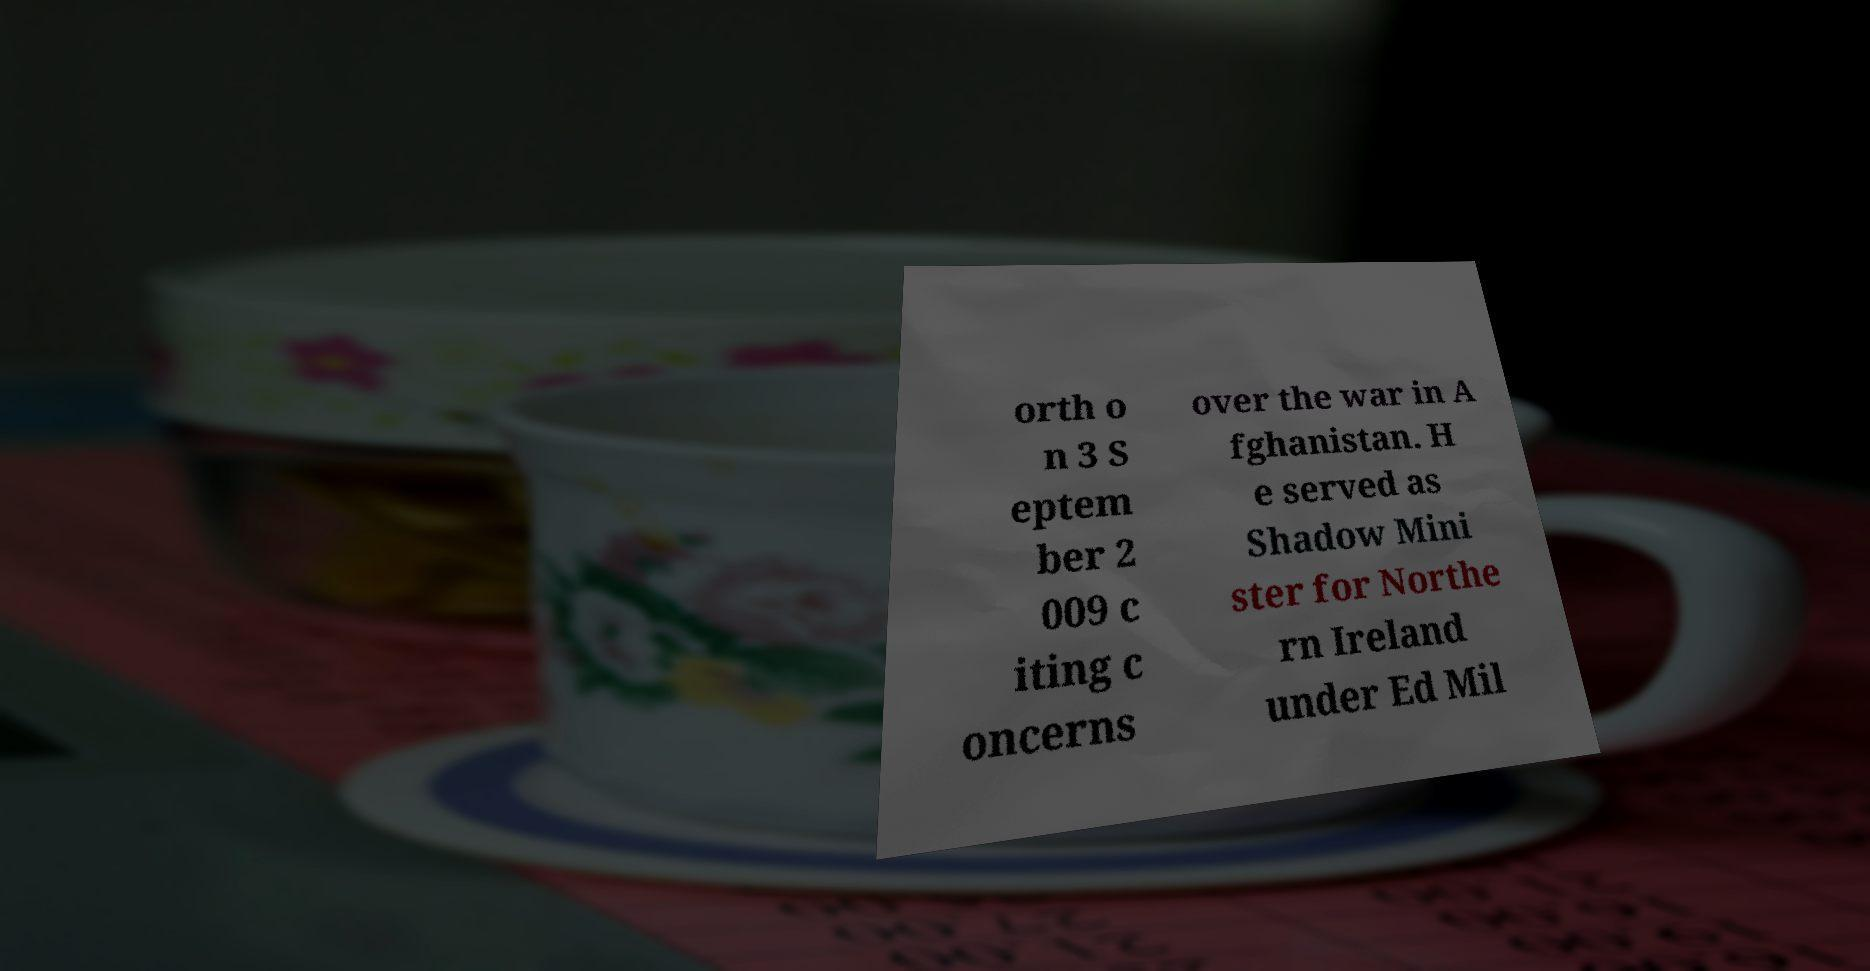I need the written content from this picture converted into text. Can you do that? orth o n 3 S eptem ber 2 009 c iting c oncerns over the war in A fghanistan. H e served as Shadow Mini ster for Northe rn Ireland under Ed Mil 